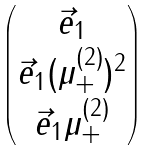Convert formula to latex. <formula><loc_0><loc_0><loc_500><loc_500>\begin{pmatrix} \vec { e } _ { 1 } \\ \vec { e } _ { 1 } ( \mu _ { + } ^ { ( 2 ) } ) ^ { 2 } \\ \vec { e } _ { 1 } \mu _ { + } ^ { ( 2 ) } \end{pmatrix}</formula> 